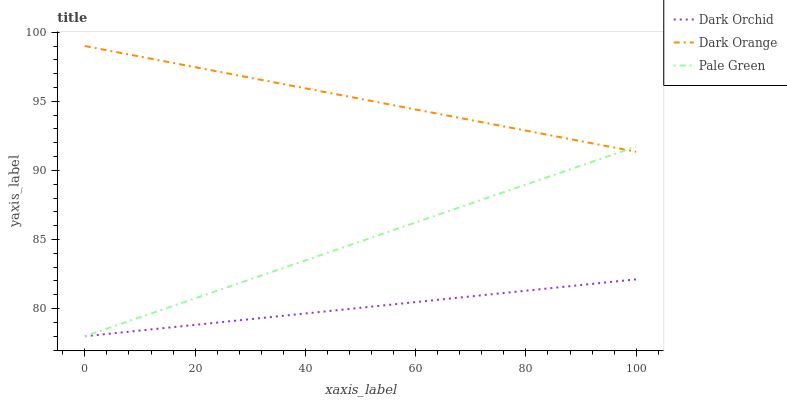Does Dark Orchid have the minimum area under the curve?
Answer yes or no. Yes. Does Dark Orange have the maximum area under the curve?
Answer yes or no. Yes. Does Pale Green have the minimum area under the curve?
Answer yes or no. No. Does Pale Green have the maximum area under the curve?
Answer yes or no. No. Is Dark Orange the smoothest?
Answer yes or no. Yes. Is Pale Green the roughest?
Answer yes or no. Yes. Is Dark Orchid the smoothest?
Answer yes or no. No. Is Dark Orchid the roughest?
Answer yes or no. No. Does Pale Green have the lowest value?
Answer yes or no. Yes. Does Dark Orange have the highest value?
Answer yes or no. Yes. Does Pale Green have the highest value?
Answer yes or no. No. Is Dark Orchid less than Dark Orange?
Answer yes or no. Yes. Is Dark Orange greater than Dark Orchid?
Answer yes or no. Yes. Does Pale Green intersect Dark Orange?
Answer yes or no. Yes. Is Pale Green less than Dark Orange?
Answer yes or no. No. Is Pale Green greater than Dark Orange?
Answer yes or no. No. Does Dark Orchid intersect Dark Orange?
Answer yes or no. No. 